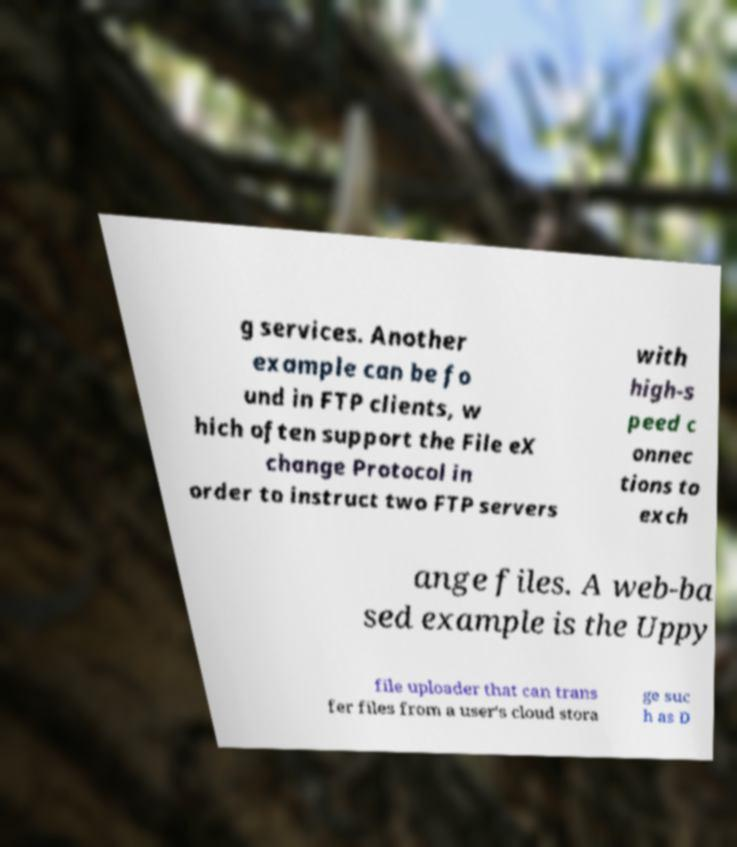Please read and relay the text visible in this image. What does it say? g services. Another example can be fo und in FTP clients, w hich often support the File eX change Protocol in order to instruct two FTP servers with high-s peed c onnec tions to exch ange files. A web-ba sed example is the Uppy file uploader that can trans fer files from a user's cloud stora ge suc h as D 